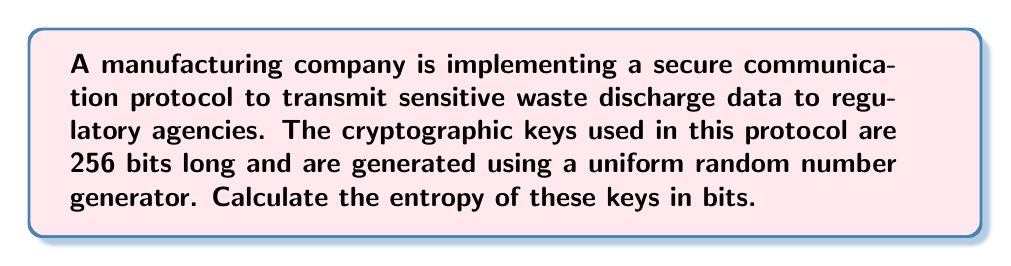Can you answer this question? To calculate the entropy of the cryptographic keys, we need to follow these steps:

1. Understand the concept of entropy in cryptography:
   Entropy is a measure of randomness or unpredictability in a system. In cryptography, it represents the amount of information contained in a key.

2. Identify the key properties:
   - Key length: 256 bits
   - Generation method: Uniform random number generator

3. Apply the entropy formula for uniformly distributed random keys:
   For a uniformly distributed random key, the entropy (H) in bits is equal to the key length in bits.

   $$H = n$$

   Where:
   $H$ = Entropy in bits
   $n$ = Key length in bits

4. Calculate the entropy:
   $$H = 256\text{ bits}$$

The entropy of the 256-bit keys used in this secure communication protocol is 256 bits. This indicates that each bit of the key contributes one bit of entropy, maximizing the unpredictability and security of the key.
Answer: 256 bits 